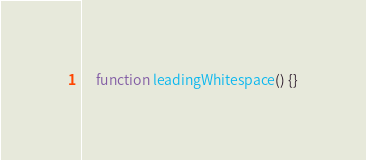Convert code to text. <code><loc_0><loc_0><loc_500><loc_500><_Awk_>	function leadingWhitespace() {}
</code> 